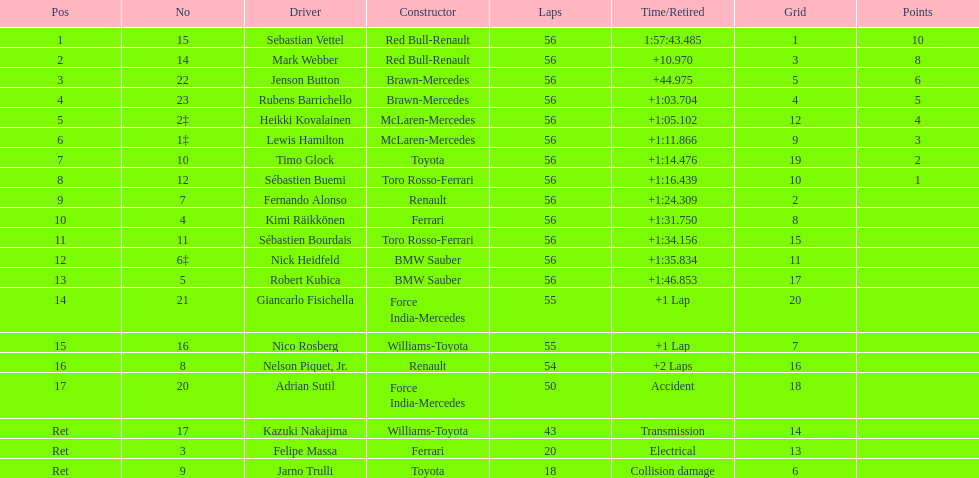What driver was last on the list? Jarno Trulli. 